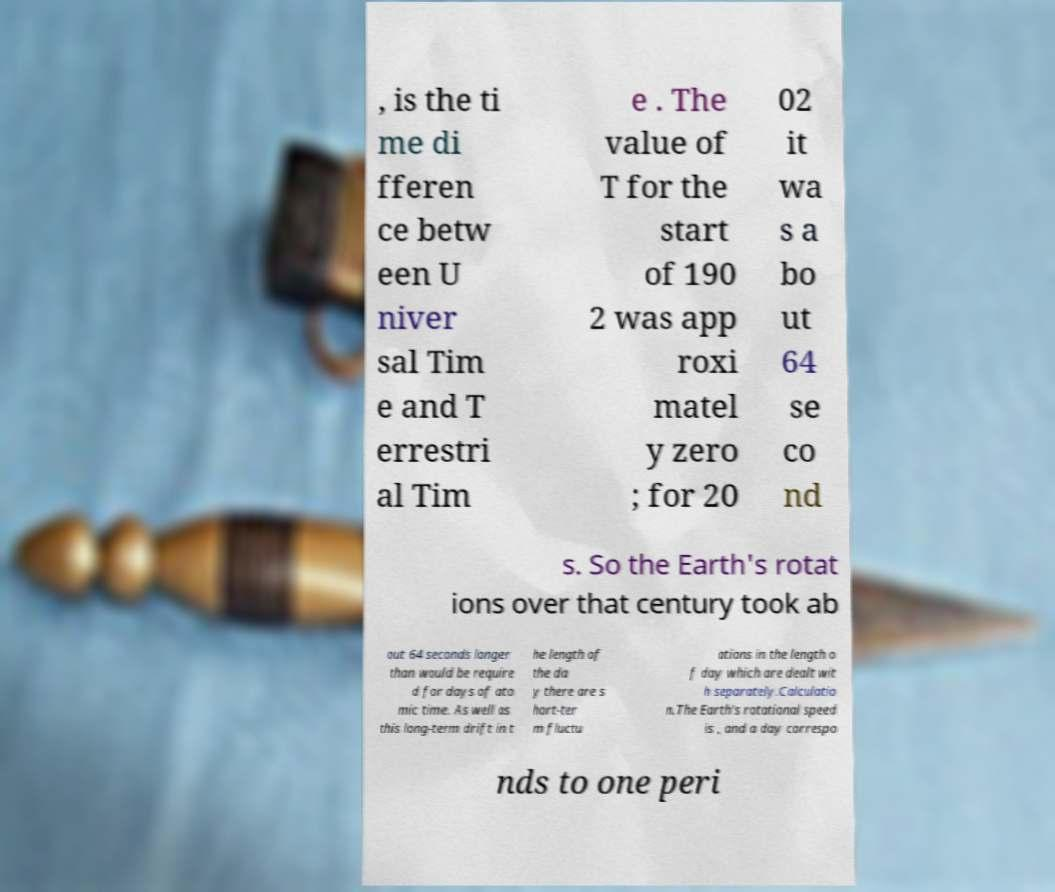Could you extract and type out the text from this image? , is the ti me di fferen ce betw een U niver sal Tim e and T errestri al Tim e . The value of T for the start of 190 2 was app roxi matel y zero ; for 20 02 it wa s a bo ut 64 se co nd s. So the Earth's rotat ions over that century took ab out 64 seconds longer than would be require d for days of ato mic time. As well as this long-term drift in t he length of the da y there are s hort-ter m fluctu ations in the length o f day which are dealt wit h separately.Calculatio n.The Earth's rotational speed is , and a day correspo nds to one peri 